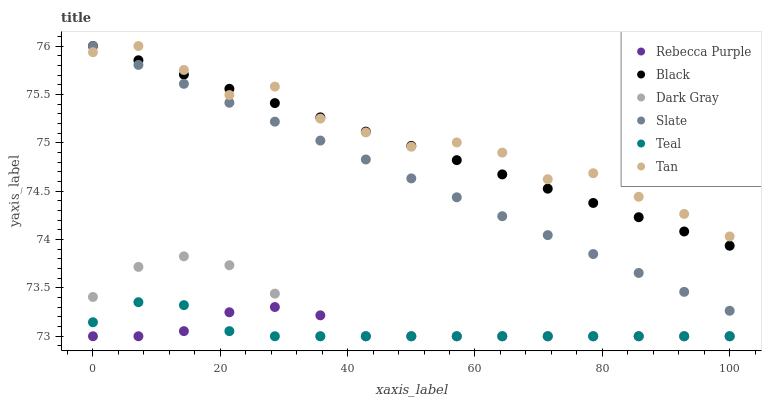Does Teal have the minimum area under the curve?
Answer yes or no. Yes. Does Tan have the maximum area under the curve?
Answer yes or no. Yes. Does Dark Gray have the minimum area under the curve?
Answer yes or no. No. Does Dark Gray have the maximum area under the curve?
Answer yes or no. No. Is Black the smoothest?
Answer yes or no. Yes. Is Tan the roughest?
Answer yes or no. Yes. Is Dark Gray the smoothest?
Answer yes or no. No. Is Dark Gray the roughest?
Answer yes or no. No. Does Dark Gray have the lowest value?
Answer yes or no. Yes. Does Black have the lowest value?
Answer yes or no. No. Does Tan have the highest value?
Answer yes or no. Yes. Does Dark Gray have the highest value?
Answer yes or no. No. Is Teal less than Black?
Answer yes or no. Yes. Is Slate greater than Dark Gray?
Answer yes or no. Yes. Does Teal intersect Rebecca Purple?
Answer yes or no. Yes. Is Teal less than Rebecca Purple?
Answer yes or no. No. Is Teal greater than Rebecca Purple?
Answer yes or no. No. Does Teal intersect Black?
Answer yes or no. No. 